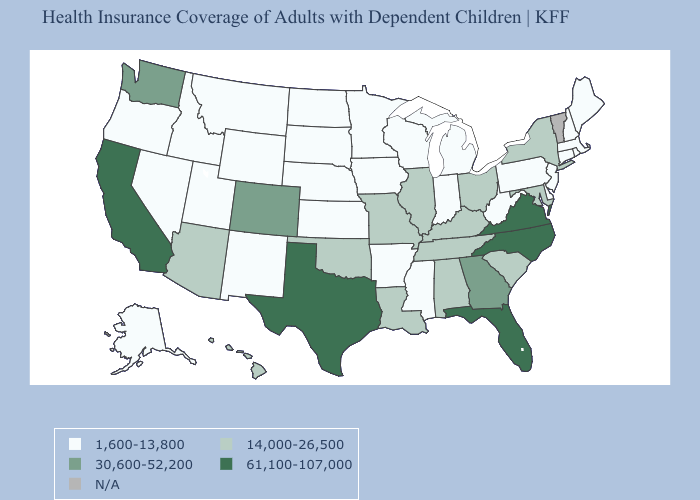Which states have the lowest value in the USA?
Short answer required. Alaska, Arkansas, Connecticut, Delaware, Idaho, Indiana, Iowa, Kansas, Maine, Massachusetts, Michigan, Minnesota, Mississippi, Montana, Nebraska, Nevada, New Hampshire, New Jersey, New Mexico, North Dakota, Oregon, Pennsylvania, Rhode Island, South Dakota, Utah, West Virginia, Wisconsin, Wyoming. Name the states that have a value in the range N/A?
Short answer required. Vermont. Name the states that have a value in the range 30,600-52,200?
Quick response, please. Colorado, Georgia, Washington. What is the value of Wisconsin?
Answer briefly. 1,600-13,800. Name the states that have a value in the range 61,100-107,000?
Concise answer only. California, Florida, North Carolina, Texas, Virginia. Which states have the lowest value in the MidWest?
Give a very brief answer. Indiana, Iowa, Kansas, Michigan, Minnesota, Nebraska, North Dakota, South Dakota, Wisconsin. What is the value of Florida?
Give a very brief answer. 61,100-107,000. Does Texas have the highest value in the USA?
Quick response, please. Yes. Which states have the lowest value in the South?
Answer briefly. Arkansas, Delaware, Mississippi, West Virginia. Among the states that border Kentucky , which have the highest value?
Answer briefly. Virginia. Among the states that border Alabama , which have the lowest value?
Keep it brief. Mississippi. Which states hav the highest value in the West?
Be succinct. California. What is the highest value in states that border Louisiana?
Concise answer only. 61,100-107,000. How many symbols are there in the legend?
Answer briefly. 5. Name the states that have a value in the range 61,100-107,000?
Keep it brief. California, Florida, North Carolina, Texas, Virginia. 